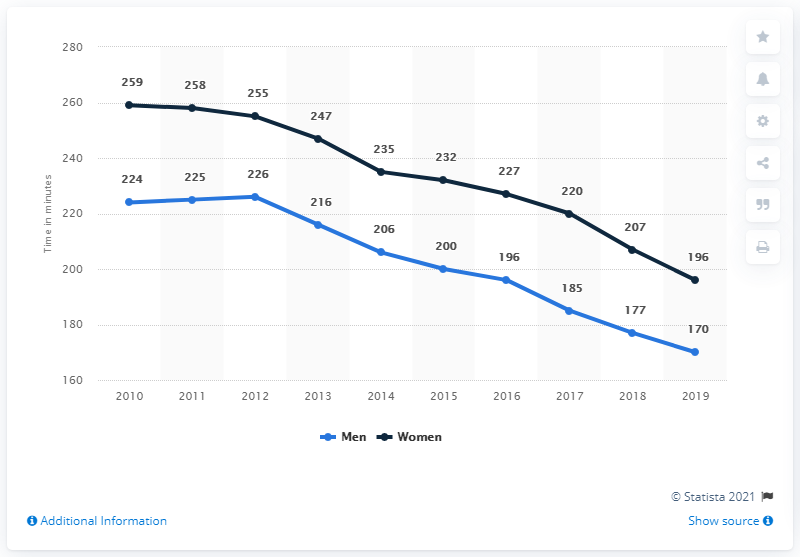Mention a couple of crucial points in this snapshot. From 2010 to present, the TV viewing of women has consistently increased. In 1960, women consumed an average of one hour and 14 minutes of television daily. The difference in the number of female viewers versus male viewers over the years has varied significantly, with the highest number of female viewers in 89 and the lowest number of male viewers in 89. In 2019, men in the UK consumed an average of 170 minutes of TV every day. 